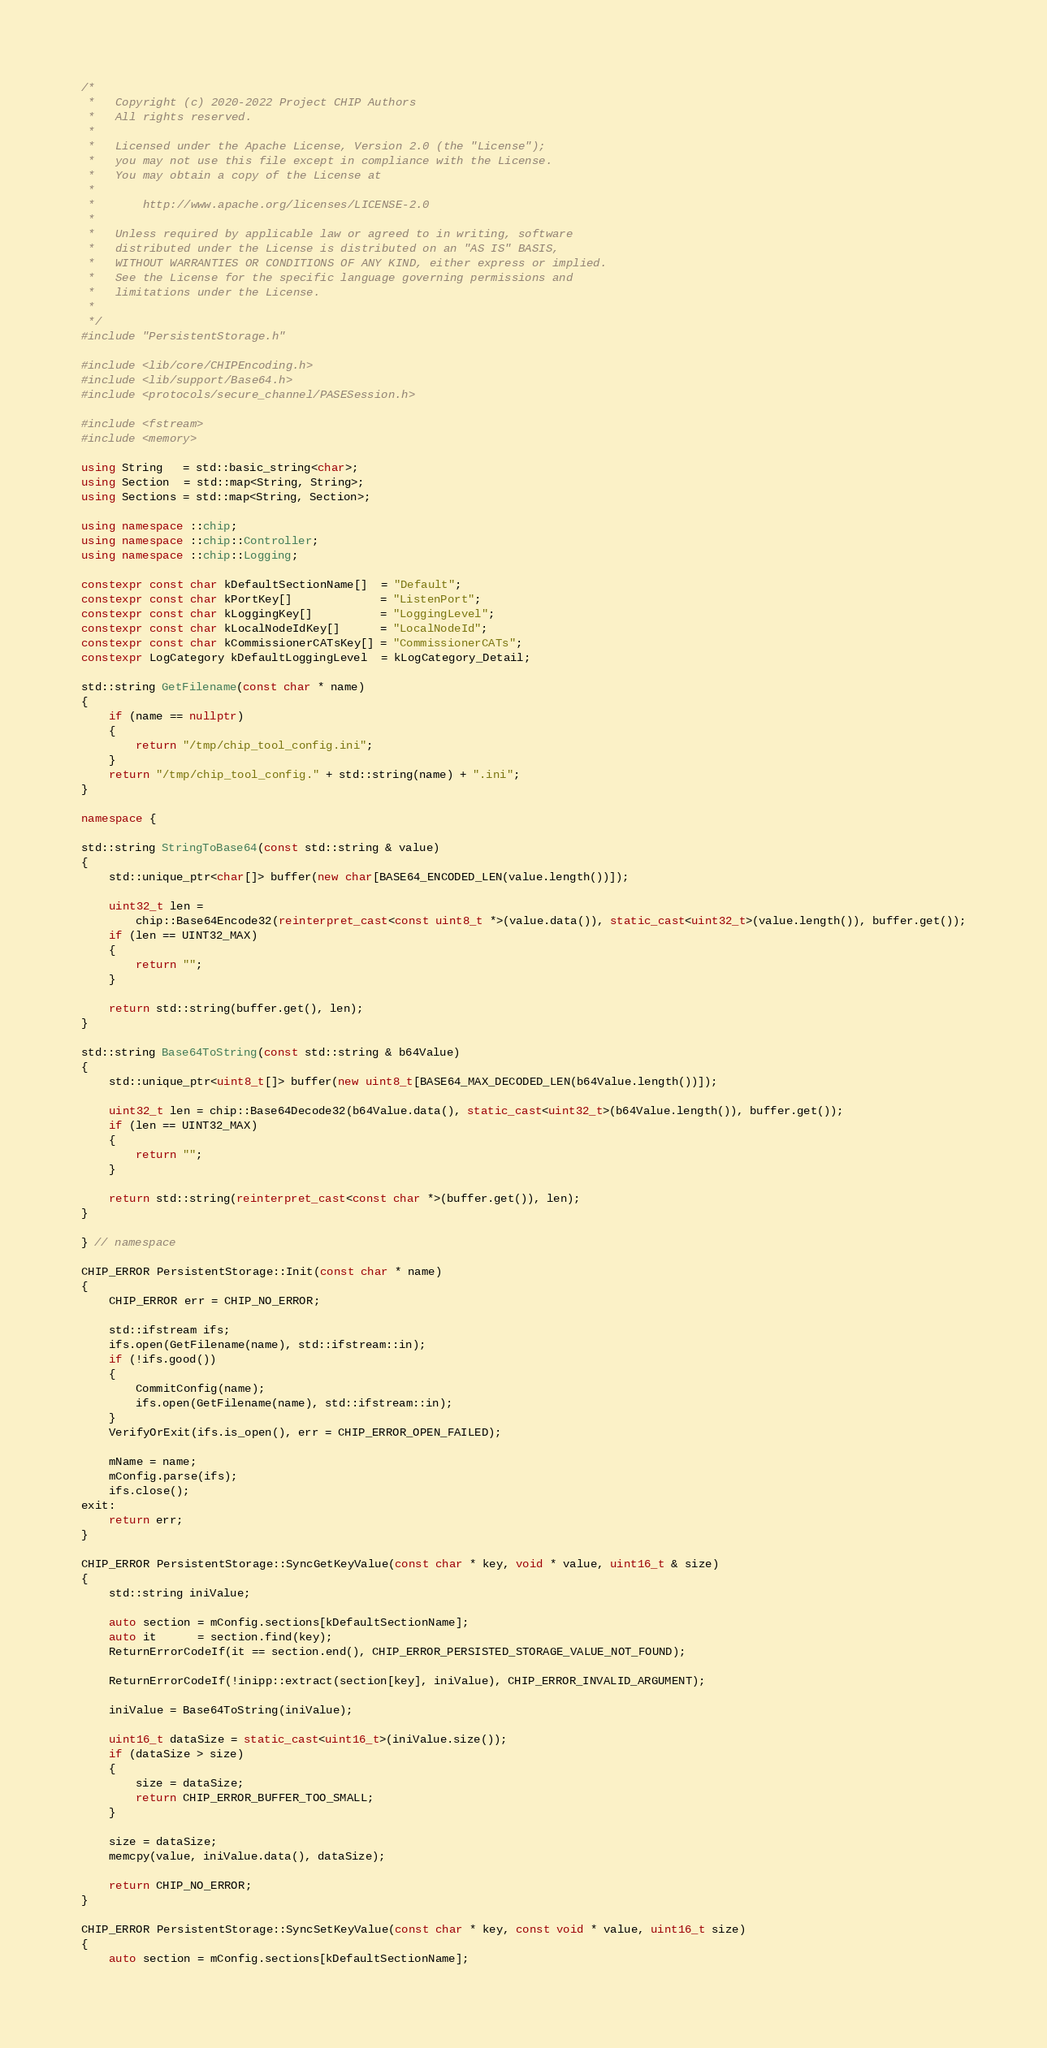Convert code to text. <code><loc_0><loc_0><loc_500><loc_500><_C++_>/*
 *   Copyright (c) 2020-2022 Project CHIP Authors
 *   All rights reserved.
 *
 *   Licensed under the Apache License, Version 2.0 (the "License");
 *   you may not use this file except in compliance with the License.
 *   You may obtain a copy of the License at
 *
 *       http://www.apache.org/licenses/LICENSE-2.0
 *
 *   Unless required by applicable law or agreed to in writing, software
 *   distributed under the License is distributed on an "AS IS" BASIS,
 *   WITHOUT WARRANTIES OR CONDITIONS OF ANY KIND, either express or implied.
 *   See the License for the specific language governing permissions and
 *   limitations under the License.
 *
 */
#include "PersistentStorage.h"

#include <lib/core/CHIPEncoding.h>
#include <lib/support/Base64.h>
#include <protocols/secure_channel/PASESession.h>

#include <fstream>
#include <memory>

using String   = std::basic_string<char>;
using Section  = std::map<String, String>;
using Sections = std::map<String, Section>;

using namespace ::chip;
using namespace ::chip::Controller;
using namespace ::chip::Logging;

constexpr const char kDefaultSectionName[]  = "Default";
constexpr const char kPortKey[]             = "ListenPort";
constexpr const char kLoggingKey[]          = "LoggingLevel";
constexpr const char kLocalNodeIdKey[]      = "LocalNodeId";
constexpr const char kCommissionerCATsKey[] = "CommissionerCATs";
constexpr LogCategory kDefaultLoggingLevel  = kLogCategory_Detail;

std::string GetFilename(const char * name)
{
    if (name == nullptr)
    {
        return "/tmp/chip_tool_config.ini";
    }
    return "/tmp/chip_tool_config." + std::string(name) + ".ini";
}

namespace {

std::string StringToBase64(const std::string & value)
{
    std::unique_ptr<char[]> buffer(new char[BASE64_ENCODED_LEN(value.length())]);

    uint32_t len =
        chip::Base64Encode32(reinterpret_cast<const uint8_t *>(value.data()), static_cast<uint32_t>(value.length()), buffer.get());
    if (len == UINT32_MAX)
    {
        return "";
    }

    return std::string(buffer.get(), len);
}

std::string Base64ToString(const std::string & b64Value)
{
    std::unique_ptr<uint8_t[]> buffer(new uint8_t[BASE64_MAX_DECODED_LEN(b64Value.length())]);

    uint32_t len = chip::Base64Decode32(b64Value.data(), static_cast<uint32_t>(b64Value.length()), buffer.get());
    if (len == UINT32_MAX)
    {
        return "";
    }

    return std::string(reinterpret_cast<const char *>(buffer.get()), len);
}

} // namespace

CHIP_ERROR PersistentStorage::Init(const char * name)
{
    CHIP_ERROR err = CHIP_NO_ERROR;

    std::ifstream ifs;
    ifs.open(GetFilename(name), std::ifstream::in);
    if (!ifs.good())
    {
        CommitConfig(name);
        ifs.open(GetFilename(name), std::ifstream::in);
    }
    VerifyOrExit(ifs.is_open(), err = CHIP_ERROR_OPEN_FAILED);

    mName = name;
    mConfig.parse(ifs);
    ifs.close();
exit:
    return err;
}

CHIP_ERROR PersistentStorage::SyncGetKeyValue(const char * key, void * value, uint16_t & size)
{
    std::string iniValue;

    auto section = mConfig.sections[kDefaultSectionName];
    auto it      = section.find(key);
    ReturnErrorCodeIf(it == section.end(), CHIP_ERROR_PERSISTED_STORAGE_VALUE_NOT_FOUND);

    ReturnErrorCodeIf(!inipp::extract(section[key], iniValue), CHIP_ERROR_INVALID_ARGUMENT);

    iniValue = Base64ToString(iniValue);

    uint16_t dataSize = static_cast<uint16_t>(iniValue.size());
    if (dataSize > size)
    {
        size = dataSize;
        return CHIP_ERROR_BUFFER_TOO_SMALL;
    }

    size = dataSize;
    memcpy(value, iniValue.data(), dataSize);

    return CHIP_NO_ERROR;
}

CHIP_ERROR PersistentStorage::SyncSetKeyValue(const char * key, const void * value, uint16_t size)
{
    auto section = mConfig.sections[kDefaultSectionName];</code> 